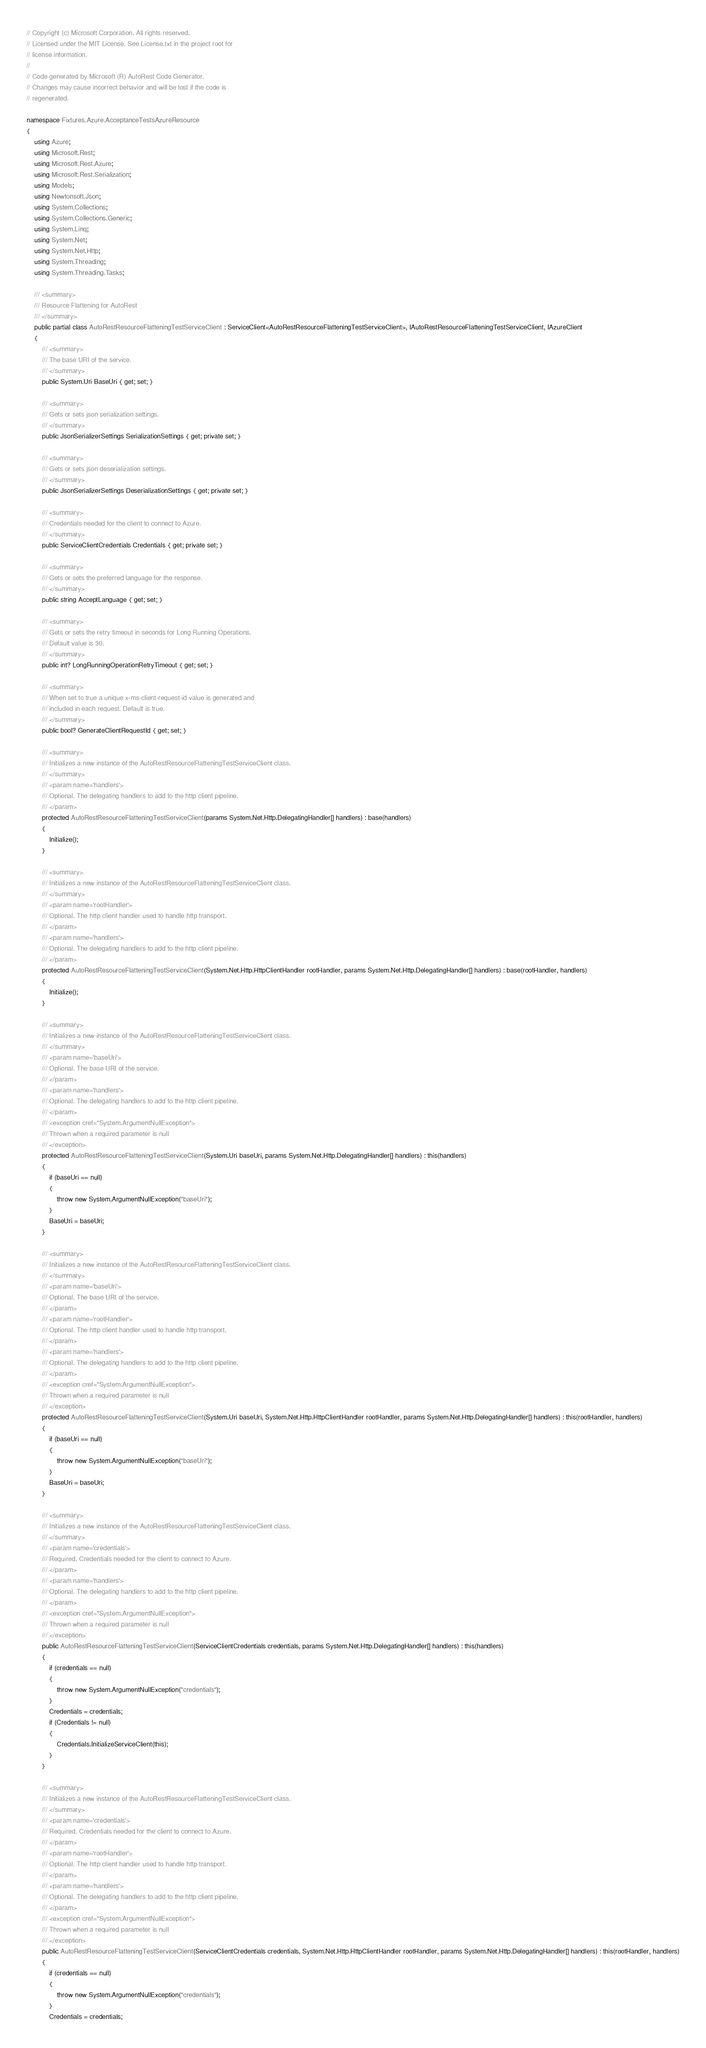<code> <loc_0><loc_0><loc_500><loc_500><_C#_>// Copyright (c) Microsoft Corporation. All rights reserved.
// Licensed under the MIT License. See License.txt in the project root for
// license information.
//
// Code generated by Microsoft (R) AutoRest Code Generator.
// Changes may cause incorrect behavior and will be lost if the code is
// regenerated.

namespace Fixtures.Azure.AcceptanceTestsAzureResource
{
    using Azure;
    using Microsoft.Rest;
    using Microsoft.Rest.Azure;
    using Microsoft.Rest.Serialization;
    using Models;
    using Newtonsoft.Json;
    using System.Collections;
    using System.Collections.Generic;
    using System.Linq;
    using System.Net;
    using System.Net.Http;
    using System.Threading;
    using System.Threading.Tasks;

    /// <summary>
    /// Resource Flattening for AutoRest
    /// </summary>
    public partial class AutoRestResourceFlatteningTestServiceClient : ServiceClient<AutoRestResourceFlatteningTestServiceClient>, IAutoRestResourceFlatteningTestServiceClient, IAzureClient
    {
        /// <summary>
        /// The base URI of the service.
        /// </summary>
        public System.Uri BaseUri { get; set; }

        /// <summary>
        /// Gets or sets json serialization settings.
        /// </summary>
        public JsonSerializerSettings SerializationSettings { get; private set; }

        /// <summary>
        /// Gets or sets json deserialization settings.
        /// </summary>
        public JsonSerializerSettings DeserializationSettings { get; private set; }

        /// <summary>
        /// Credentials needed for the client to connect to Azure.
        /// </summary>
        public ServiceClientCredentials Credentials { get; private set; }

        /// <summary>
        /// Gets or sets the preferred language for the response.
        /// </summary>
        public string AcceptLanguage { get; set; }

        /// <summary>
        /// Gets or sets the retry timeout in seconds for Long Running Operations.
        /// Default value is 30.
        /// </summary>
        public int? LongRunningOperationRetryTimeout { get; set; }

        /// <summary>
        /// When set to true a unique x-ms-client-request-id value is generated and
        /// included in each request. Default is true.
        /// </summary>
        public bool? GenerateClientRequestId { get; set; }

        /// <summary>
        /// Initializes a new instance of the AutoRestResourceFlatteningTestServiceClient class.
        /// </summary>
        /// <param name='handlers'>
        /// Optional. The delegating handlers to add to the http client pipeline.
        /// </param>
        protected AutoRestResourceFlatteningTestServiceClient(params System.Net.Http.DelegatingHandler[] handlers) : base(handlers)
        {
            Initialize();
        }

        /// <summary>
        /// Initializes a new instance of the AutoRestResourceFlatteningTestServiceClient class.
        /// </summary>
        /// <param name='rootHandler'>
        /// Optional. The http client handler used to handle http transport.
        /// </param>
        /// <param name='handlers'>
        /// Optional. The delegating handlers to add to the http client pipeline.
        /// </param>
        protected AutoRestResourceFlatteningTestServiceClient(System.Net.Http.HttpClientHandler rootHandler, params System.Net.Http.DelegatingHandler[] handlers) : base(rootHandler, handlers)
        {
            Initialize();
        }

        /// <summary>
        /// Initializes a new instance of the AutoRestResourceFlatteningTestServiceClient class.
        /// </summary>
        /// <param name='baseUri'>
        /// Optional. The base URI of the service.
        /// </param>
        /// <param name='handlers'>
        /// Optional. The delegating handlers to add to the http client pipeline.
        /// </param>
        /// <exception cref="System.ArgumentNullException">
        /// Thrown when a required parameter is null
        /// </exception>
        protected AutoRestResourceFlatteningTestServiceClient(System.Uri baseUri, params System.Net.Http.DelegatingHandler[] handlers) : this(handlers)
        {
            if (baseUri == null)
            {
                throw new System.ArgumentNullException("baseUri");
            }
            BaseUri = baseUri;
        }

        /// <summary>
        /// Initializes a new instance of the AutoRestResourceFlatteningTestServiceClient class.
        /// </summary>
        /// <param name='baseUri'>
        /// Optional. The base URI of the service.
        /// </param>
        /// <param name='rootHandler'>
        /// Optional. The http client handler used to handle http transport.
        /// </param>
        /// <param name='handlers'>
        /// Optional. The delegating handlers to add to the http client pipeline.
        /// </param>
        /// <exception cref="System.ArgumentNullException">
        /// Thrown when a required parameter is null
        /// </exception>
        protected AutoRestResourceFlatteningTestServiceClient(System.Uri baseUri, System.Net.Http.HttpClientHandler rootHandler, params System.Net.Http.DelegatingHandler[] handlers) : this(rootHandler, handlers)
        {
            if (baseUri == null)
            {
                throw new System.ArgumentNullException("baseUri");
            }
            BaseUri = baseUri;
        }

        /// <summary>
        /// Initializes a new instance of the AutoRestResourceFlatteningTestServiceClient class.
        /// </summary>
        /// <param name='credentials'>
        /// Required. Credentials needed for the client to connect to Azure.
        /// </param>
        /// <param name='handlers'>
        /// Optional. The delegating handlers to add to the http client pipeline.
        /// </param>
        /// <exception cref="System.ArgumentNullException">
        /// Thrown when a required parameter is null
        /// </exception>
        public AutoRestResourceFlatteningTestServiceClient(ServiceClientCredentials credentials, params System.Net.Http.DelegatingHandler[] handlers) : this(handlers)
        {
            if (credentials == null)
            {
                throw new System.ArgumentNullException("credentials");
            }
            Credentials = credentials;
            if (Credentials != null)
            {
                Credentials.InitializeServiceClient(this);
            }
        }

        /// <summary>
        /// Initializes a new instance of the AutoRestResourceFlatteningTestServiceClient class.
        /// </summary>
        /// <param name='credentials'>
        /// Required. Credentials needed for the client to connect to Azure.
        /// </param>
        /// <param name='rootHandler'>
        /// Optional. The http client handler used to handle http transport.
        /// </param>
        /// <param name='handlers'>
        /// Optional. The delegating handlers to add to the http client pipeline.
        /// </param>
        /// <exception cref="System.ArgumentNullException">
        /// Thrown when a required parameter is null
        /// </exception>
        public AutoRestResourceFlatteningTestServiceClient(ServiceClientCredentials credentials, System.Net.Http.HttpClientHandler rootHandler, params System.Net.Http.DelegatingHandler[] handlers) : this(rootHandler, handlers)
        {
            if (credentials == null)
            {
                throw new System.ArgumentNullException("credentials");
            }
            Credentials = credentials;</code> 